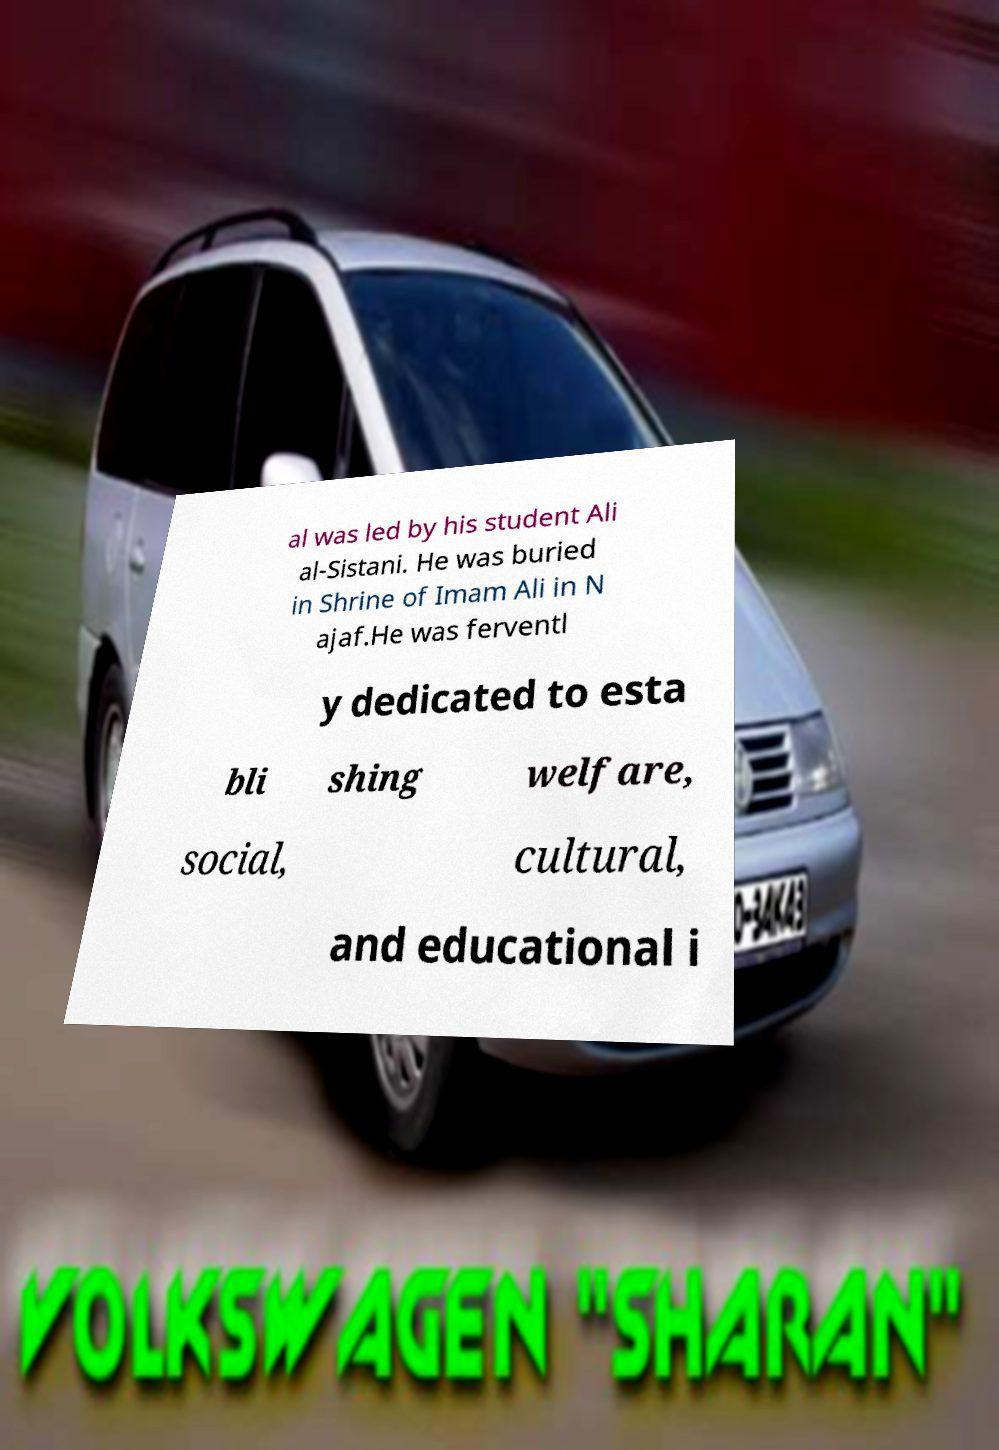Please read and relay the text visible in this image. What does it say? al was led by his student Ali al-Sistani. He was buried in Shrine of Imam Ali in N ajaf.He was ferventl y dedicated to esta bli shing welfare, social, cultural, and educational i 